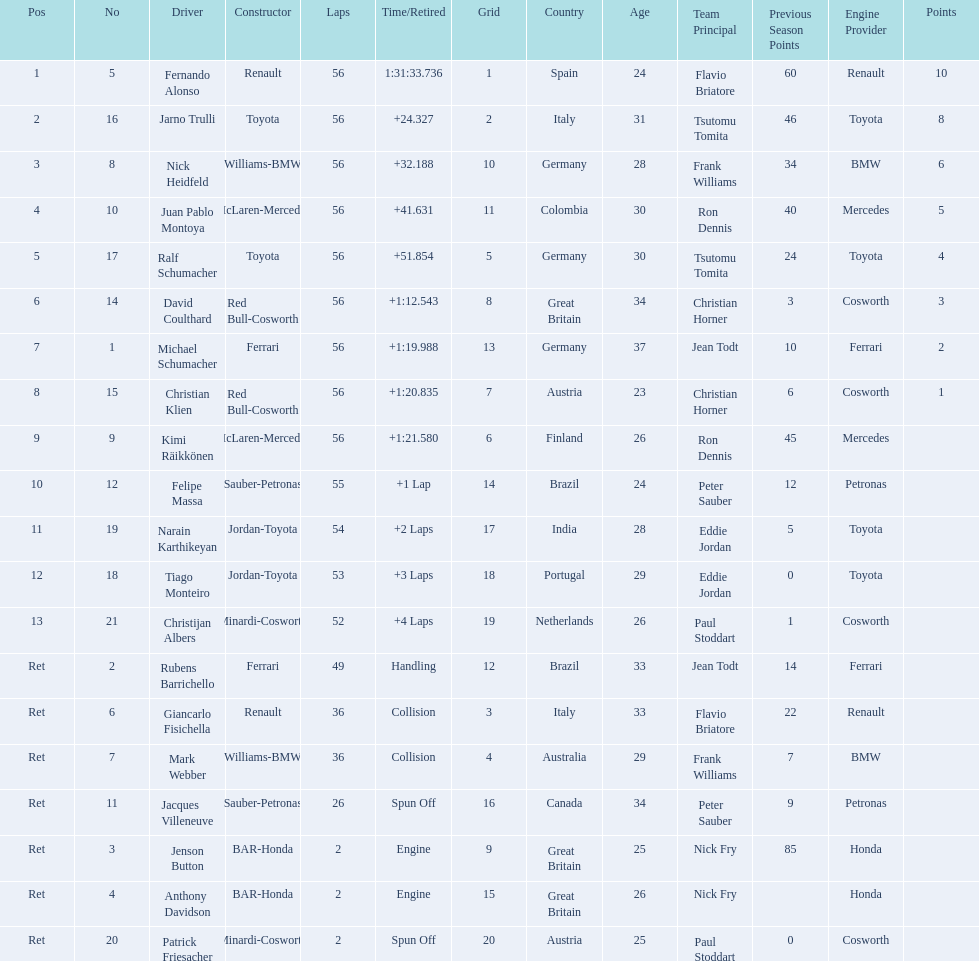Who was fernando alonso's instructor? Renault. How many laps did fernando alonso run? 56. How long did it take alonso to complete the race? 1:31:33.736. 